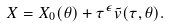Convert formula to latex. <formula><loc_0><loc_0><loc_500><loc_500>X = X _ { 0 } ( \theta ) + \tau ^ { \epsilon } \tilde { v } ( \tau , \theta ) .</formula> 